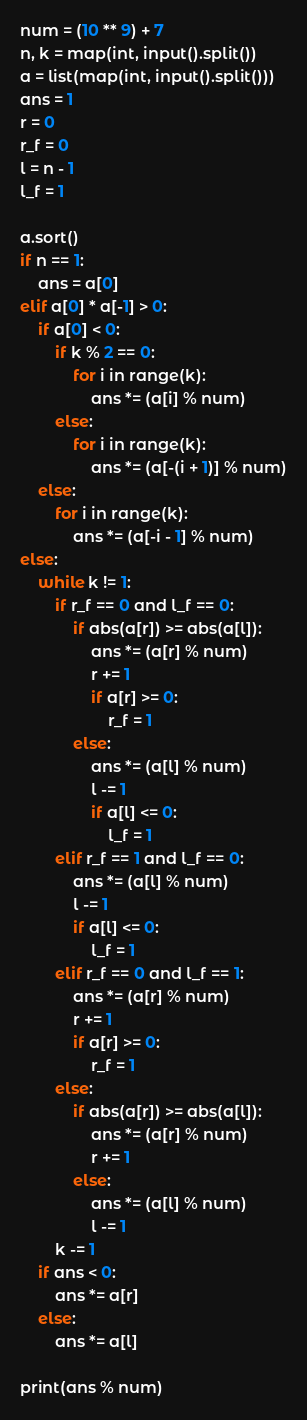<code> <loc_0><loc_0><loc_500><loc_500><_Python_>num = (10 ** 9) + 7
n, k = map(int, input().split())
a = list(map(int, input().split()))
ans = 1
r = 0
r_f = 0
l = n - 1
l_f = 1

a.sort()
if n == 1:
    ans = a[0]
elif a[0] * a[-1] > 0:
    if a[0] < 0:
        if k % 2 == 0:
            for i in range(k):
                ans *= (a[i] % num)
        else:
            for i in range(k):
                ans *= (a[-(i + 1)] % num)
    else:
        for i in range(k):
            ans *= (a[-i - 1] % num)
else:
    while k != 1:
        if r_f == 0 and l_f == 0:
            if abs(a[r]) >= abs(a[l]):
                ans *= (a[r] % num)
                r += 1
                if a[r] >= 0:
                    r_f = 1
            else:
                ans *= (a[l] % num)
                l -= 1
                if a[l] <= 0:
                    l_f = 1
        elif r_f == 1 and l_f == 0:
            ans *= (a[l] % num)
            l -= 1
            if a[l] <= 0:
                l_f = 1
        elif r_f == 0 and l_f == 1:
            ans *= (a[r] % num)
            r += 1
            if a[r] >= 0:
                r_f = 1
        else:
            if abs(a[r]) >= abs(a[l]):
                ans *= (a[r] % num)
                r += 1
            else:
                ans *= (a[l] % num)
                l -= 1
        k -= 1
    if ans < 0:
        ans *= a[r]
    else:
        ans *= a[l]

print(ans % num)</code> 